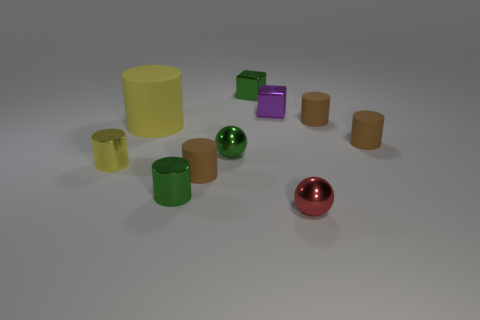There is a tiny purple block; how many small matte cylinders are right of it?
Provide a succinct answer. 2. There is a tiny thing that is the same color as the big object; what material is it?
Offer a very short reply. Metal. What number of tiny things are green shiny objects or rubber cylinders?
Ensure brevity in your answer.  6. What is the shape of the matte object that is behind the large cylinder?
Your response must be concise. Cylinder. Are there any shiny objects of the same color as the big cylinder?
Offer a terse response. Yes. Does the brown cylinder on the left side of the small red metal thing have the same size as the rubber object that is behind the yellow matte cylinder?
Provide a succinct answer. Yes. Is the number of small brown rubber things in front of the green ball greater than the number of large yellow things that are behind the small green metallic block?
Provide a succinct answer. Yes. Are there any yellow cylinders that have the same material as the small green block?
Provide a succinct answer. Yes. There is a object that is behind the large yellow rubber cylinder and to the left of the tiny purple object; what is its material?
Provide a short and direct response. Metal. The big cylinder is what color?
Keep it short and to the point. Yellow. 